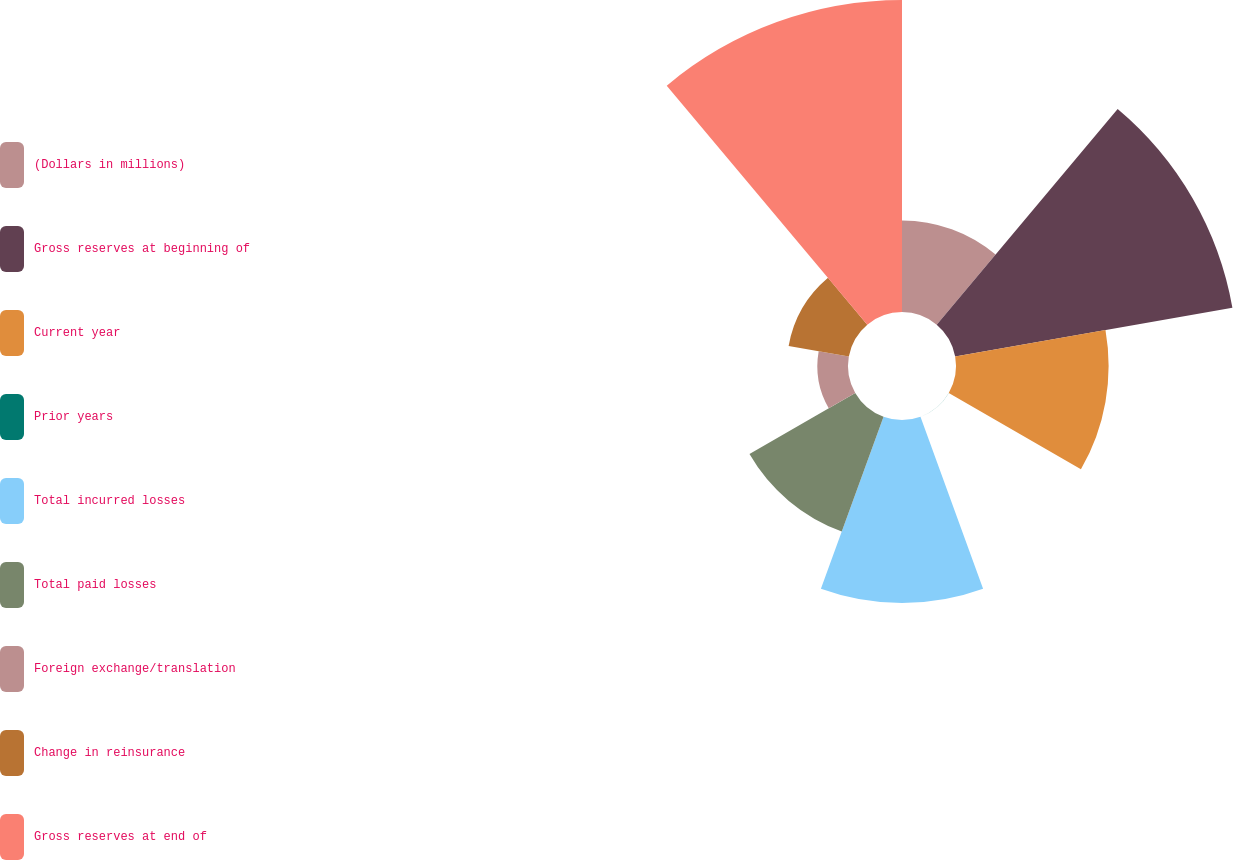<chart> <loc_0><loc_0><loc_500><loc_500><pie_chart><fcel>(Dollars in millions)<fcel>Gross reserves at beginning of<fcel>Current year<fcel>Prior years<fcel>Total incurred losses<fcel>Total paid losses<fcel>Foreign exchange/translation<fcel>Change in reinsurance<fcel>Gross reserves at end of<nl><fcel>7.42%<fcel>22.8%<fcel>12.36%<fcel>0.01%<fcel>14.83%<fcel>9.89%<fcel>2.48%<fcel>4.95%<fcel>25.27%<nl></chart> 